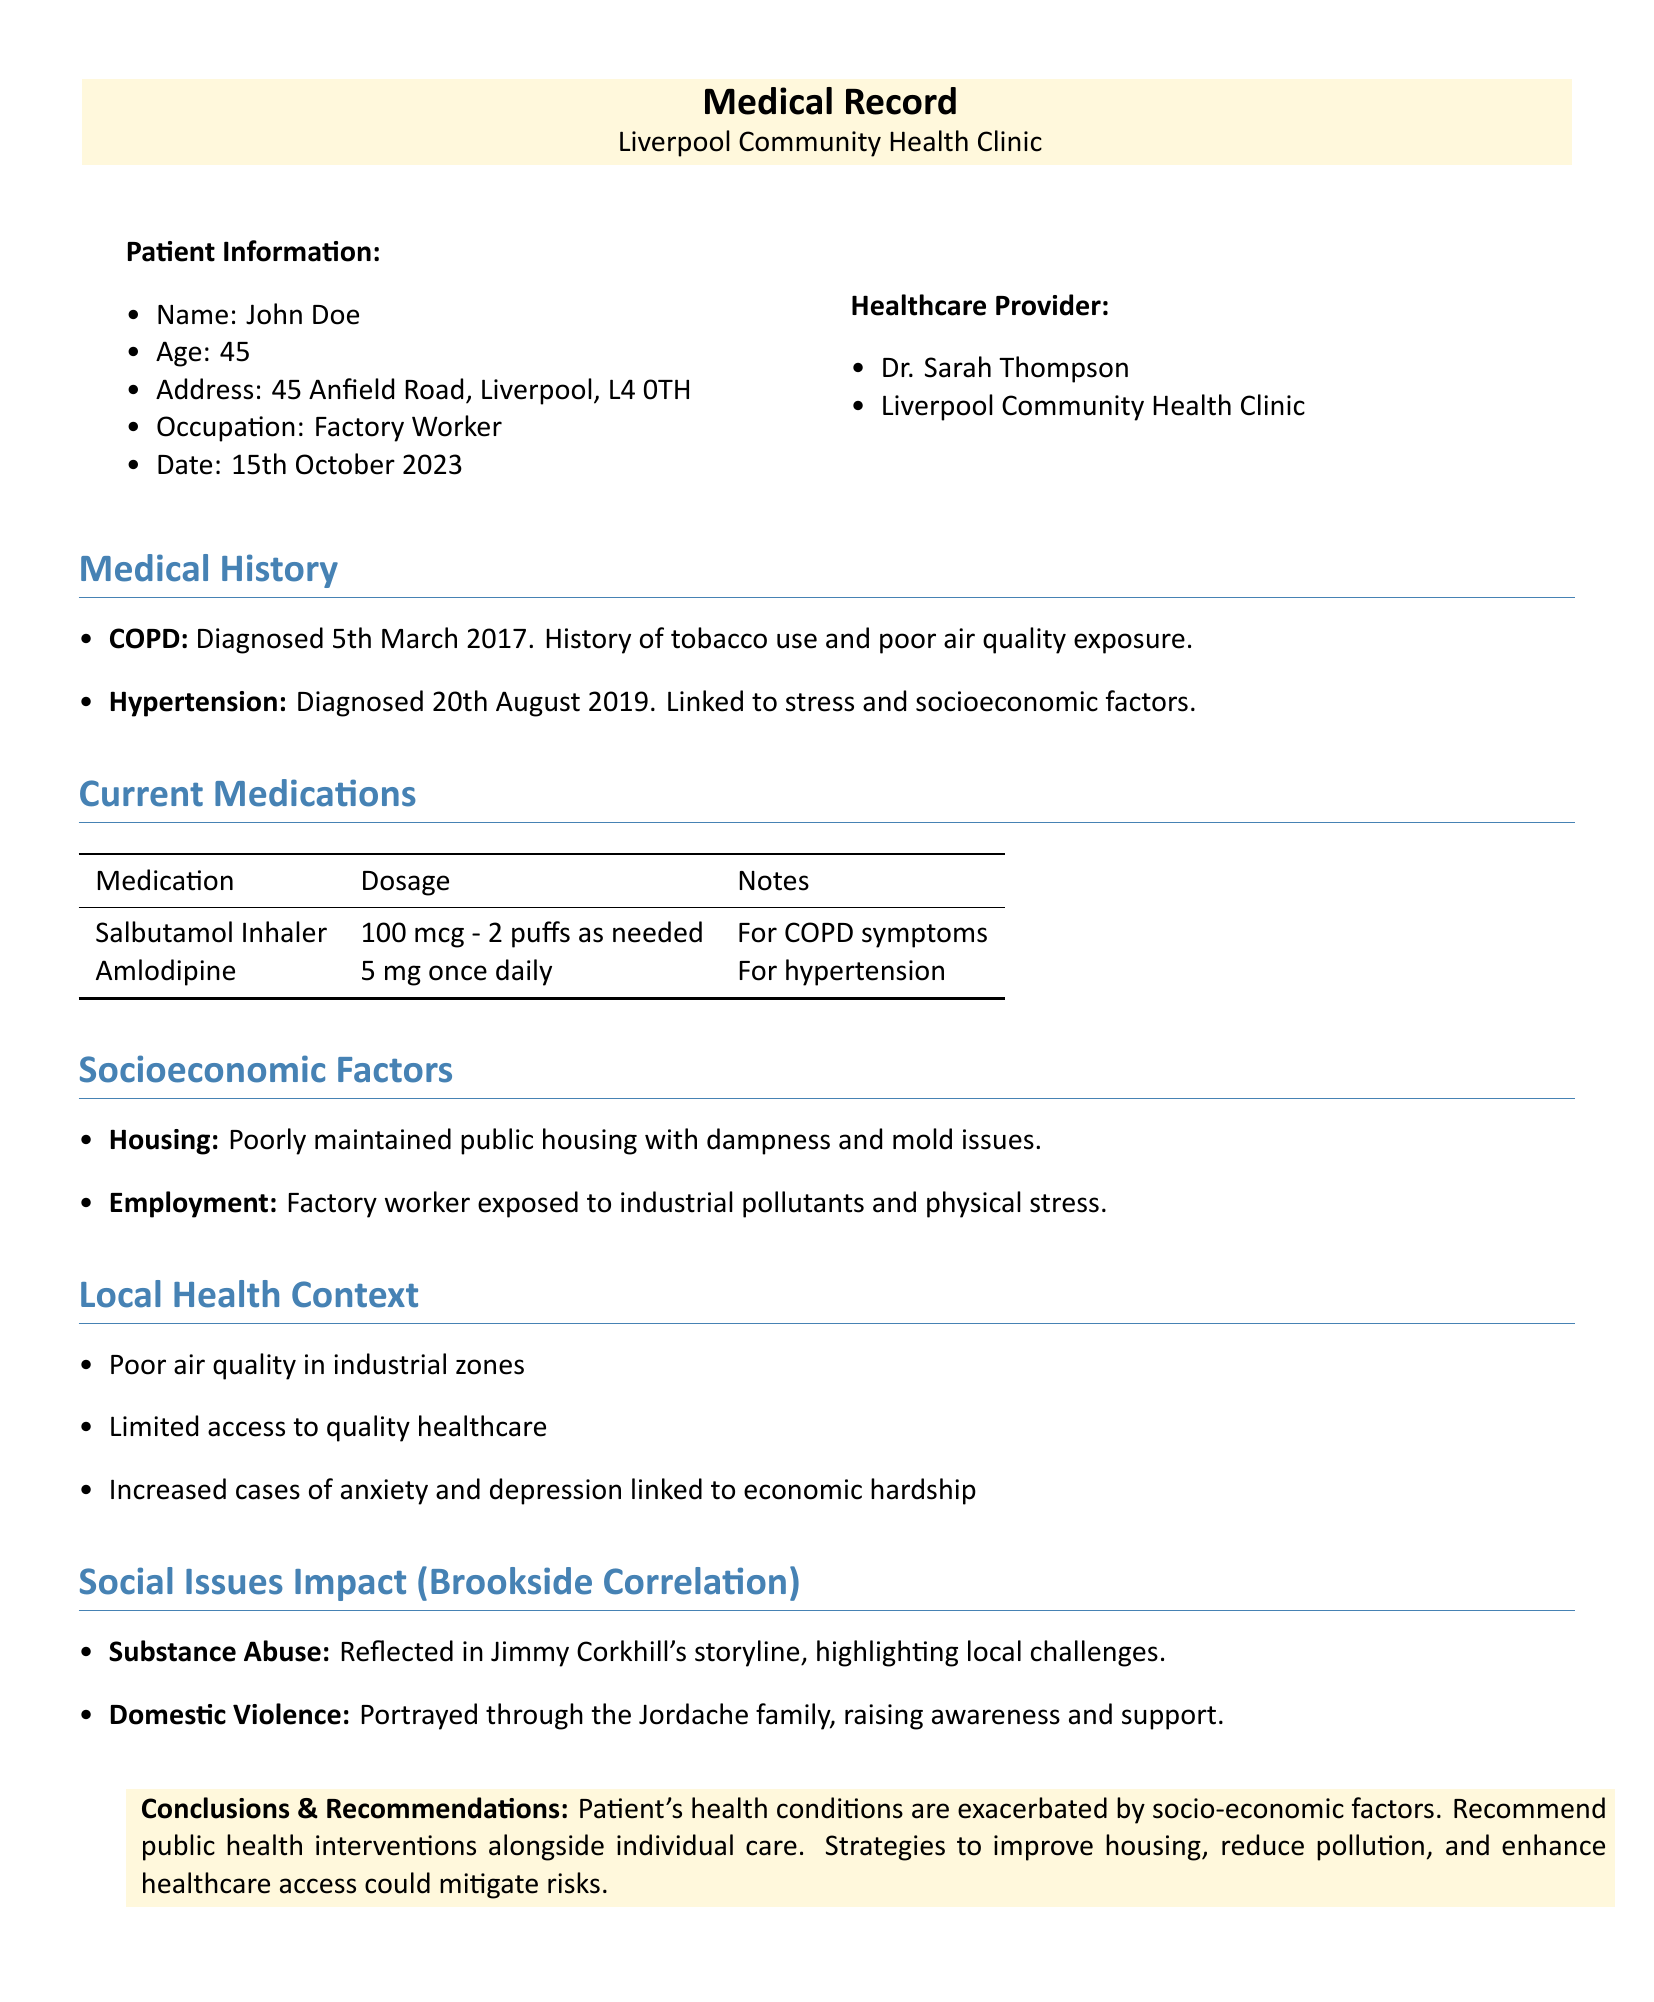What is the patient's name? The patient's name is listed in the Patient Information section.
Answer: John Doe What is the patient's age? The patient's age is mentioned under Patient Information.
Answer: 45 What healthcare provider is listed? The healthcare provider's information is provided in the document.
Answer: Dr. Sarah Thompson When was the patient's COPD diagnosed? The date of COPD diagnosis is specified in the Medical History section.
Answer: 5th March 2017 What is one socioeconomic factor affecting the patient? The socioeconomic factors are detailed in the corresponding section.
Answer: Poorly maintained public housing What health issue is linked to stress in the patient? This health issue is mentioned in the Medical History section.
Answer: Hypertension What local social issue is highlighted by Jimmy Corkhill's storyline? The social issues are discussed in the Social Issues Impact section.
Answer: Substance Abuse What recommendation is given to improve healthcare access? The recommendations are provided in the Conclusions & Recommendations section.
Answer: Public health interventions Which medication is prescribed for COPD symptoms? The Current Medications section lists medications and their purposes.
Answer: Salbutamol Inhaler What is a consequence of poor air quality mentioned in the document? The local health context touches on the consequences of poor air quality.
Answer: Increased cases of anxiety and depression 